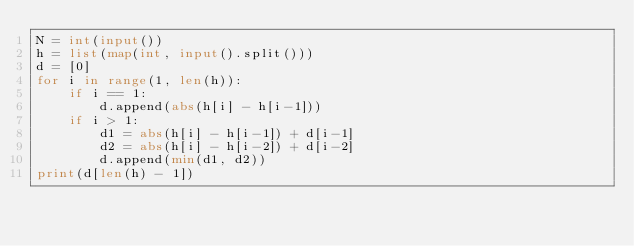<code> <loc_0><loc_0><loc_500><loc_500><_Python_>N = int(input())
h = list(map(int, input().split()))
d = [0]
for i in range(1, len(h)):
    if i == 1:
        d.append(abs(h[i] - h[i-1]))
    if i > 1:
        d1 = abs(h[i] - h[i-1]) + d[i-1]
        d2 = abs(h[i] - h[i-2]) + d[i-2]
        d.append(min(d1, d2))
print(d[len(h) - 1])</code> 